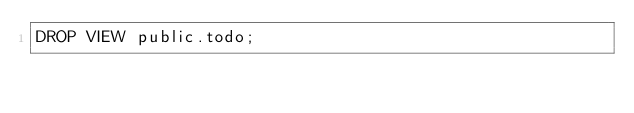Convert code to text. <code><loc_0><loc_0><loc_500><loc_500><_SQL_>DROP VIEW public.todo;</code> 